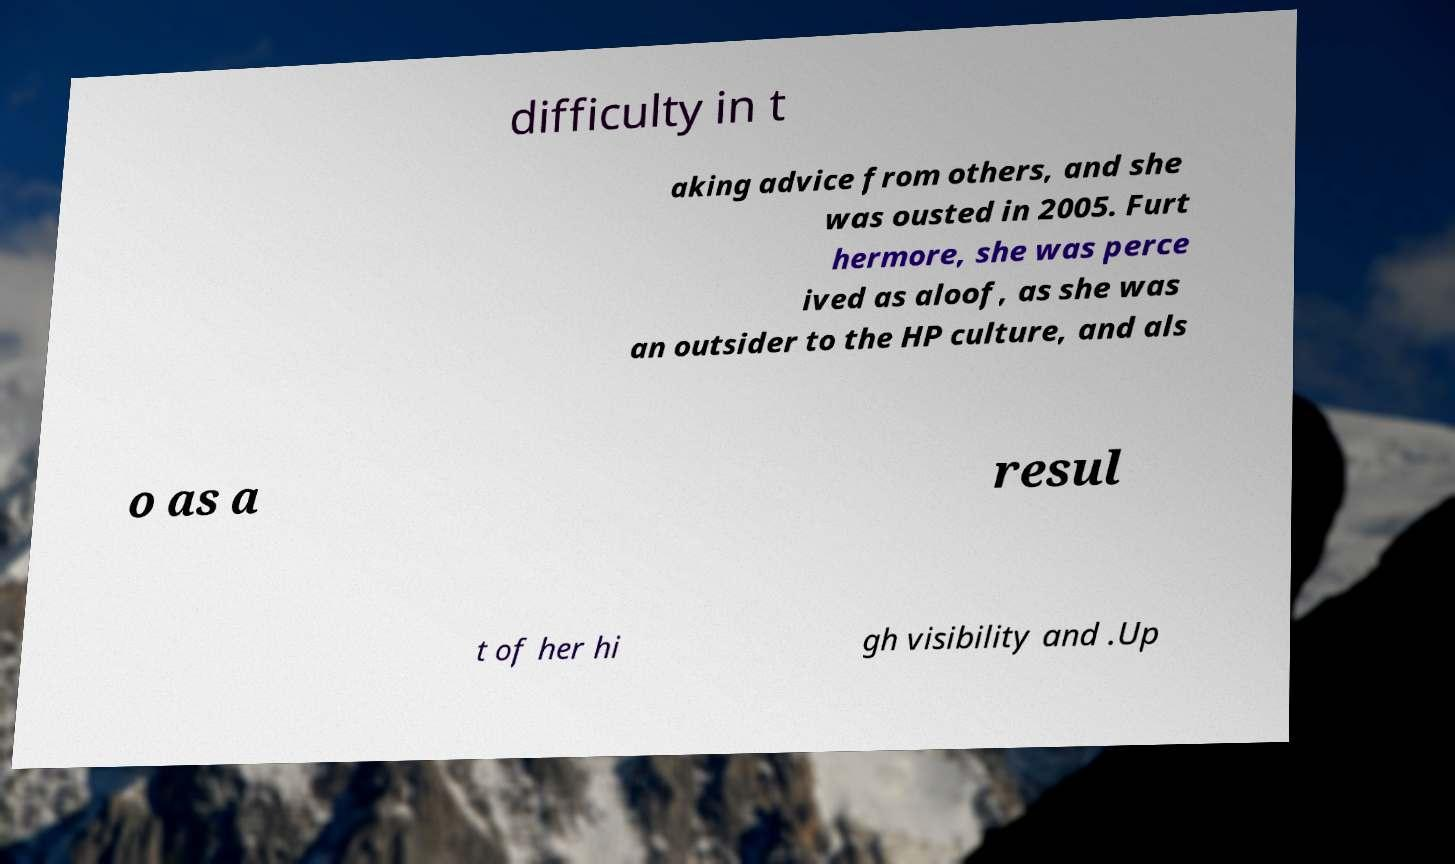What messages or text are displayed in this image? I need them in a readable, typed format. difficulty in t aking advice from others, and she was ousted in 2005. Furt hermore, she was perce ived as aloof, as she was an outsider to the HP culture, and als o as a resul t of her hi gh visibility and .Up 